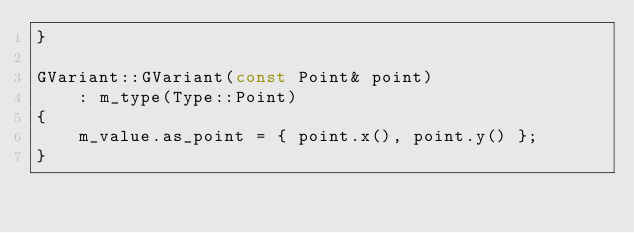<code> <loc_0><loc_0><loc_500><loc_500><_C++_>}

GVariant::GVariant(const Point& point)
    : m_type(Type::Point)
{
    m_value.as_point = { point.x(), point.y() };
}
</code> 